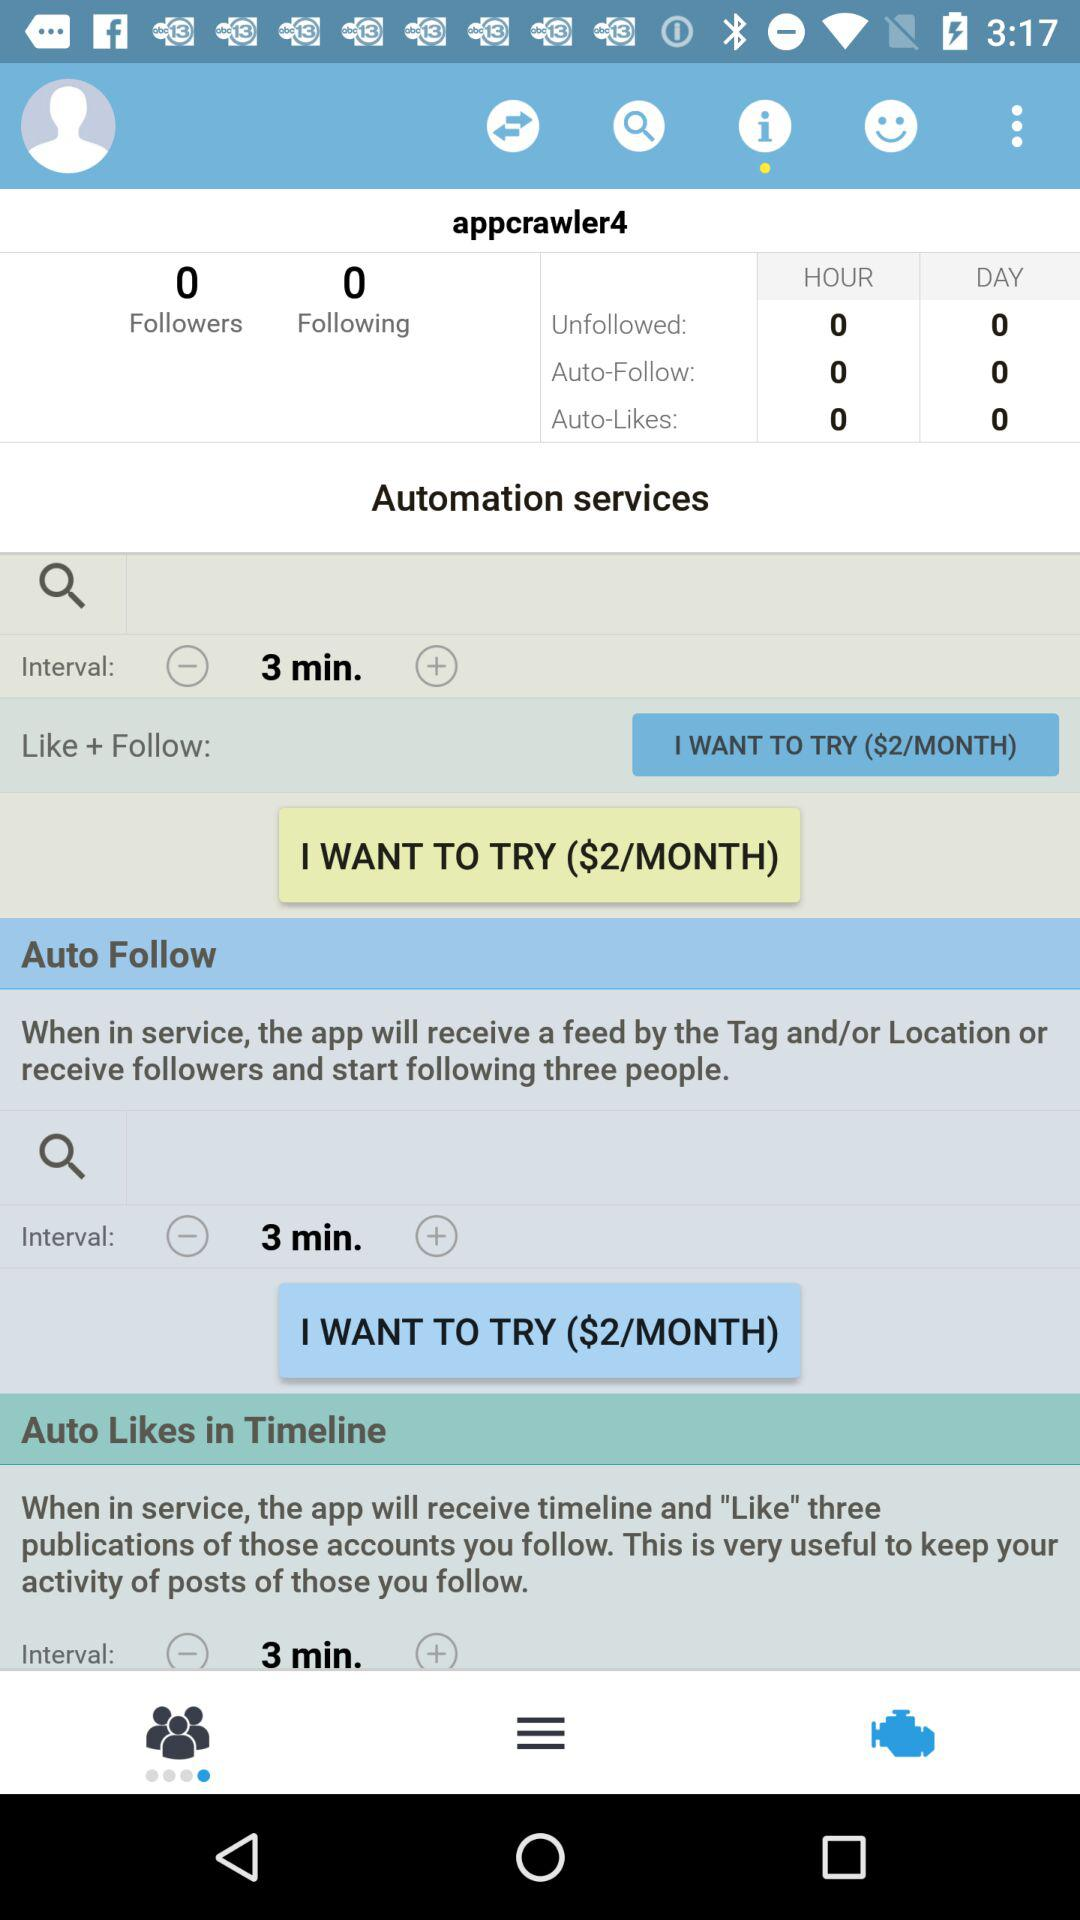What is the interval time? The interval time is 3 minutes. 